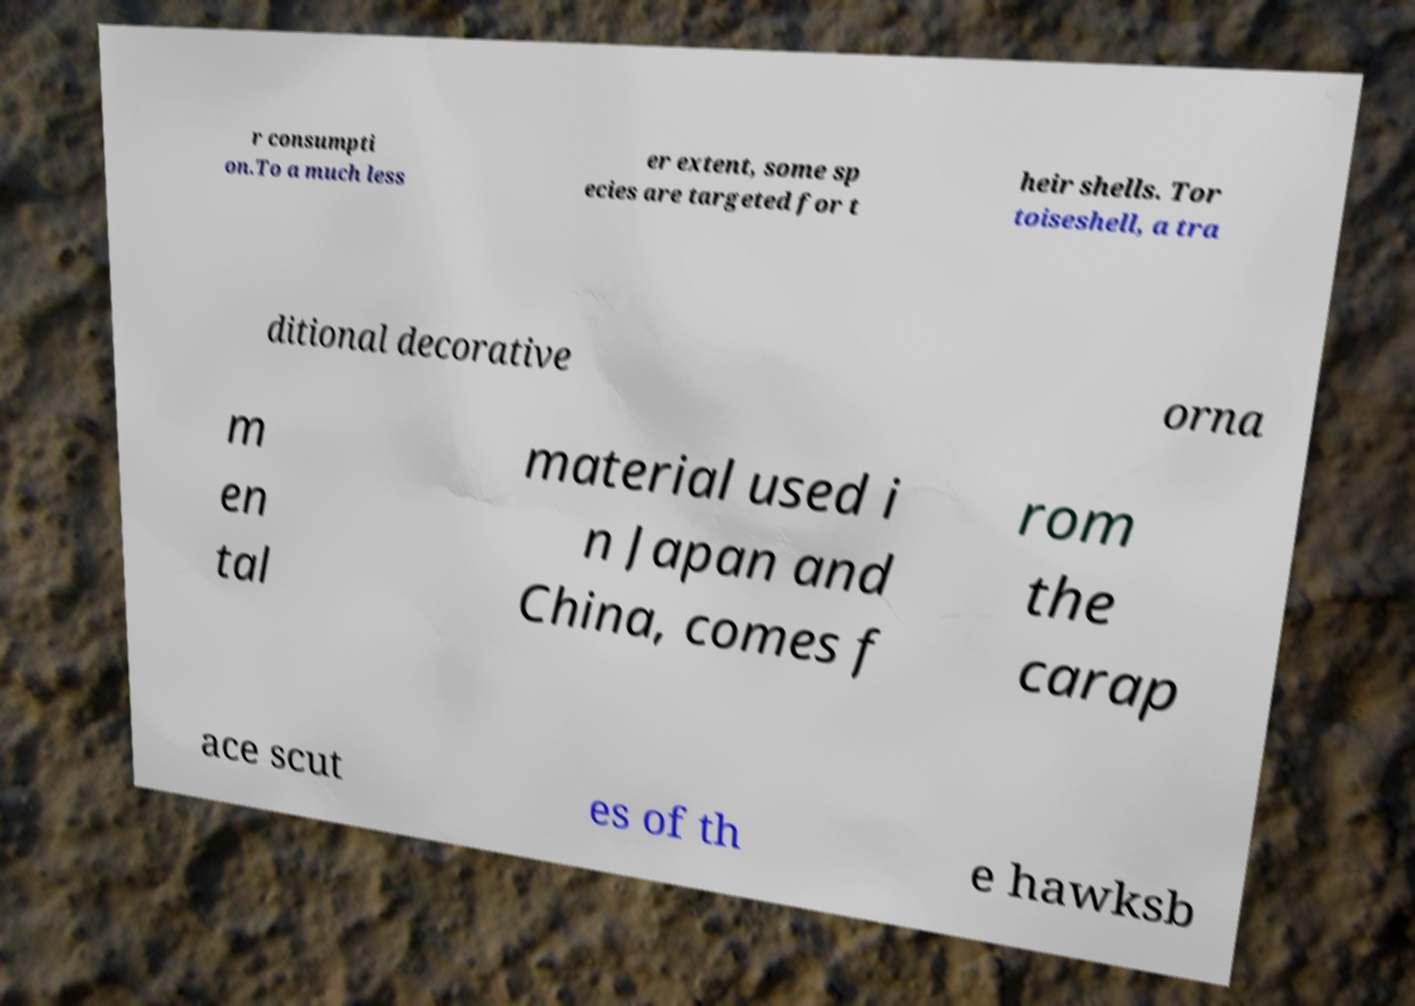Please identify and transcribe the text found in this image. r consumpti on.To a much less er extent, some sp ecies are targeted for t heir shells. Tor toiseshell, a tra ditional decorative orna m en tal material used i n Japan and China, comes f rom the carap ace scut es of th e hawksb 